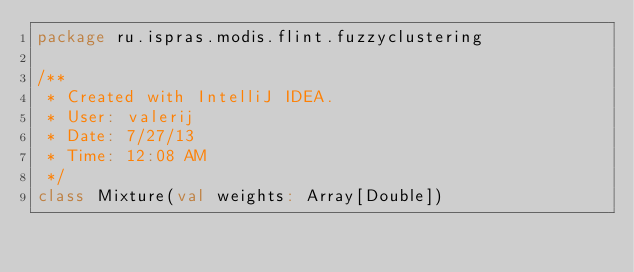<code> <loc_0><loc_0><loc_500><loc_500><_Scala_>package ru.ispras.modis.flint.fuzzyclustering

/**
 * Created with IntelliJ IDEA.
 * User: valerij
 * Date: 7/27/13
 * Time: 12:08 AM
 */
class Mixture(val weights: Array[Double])</code> 